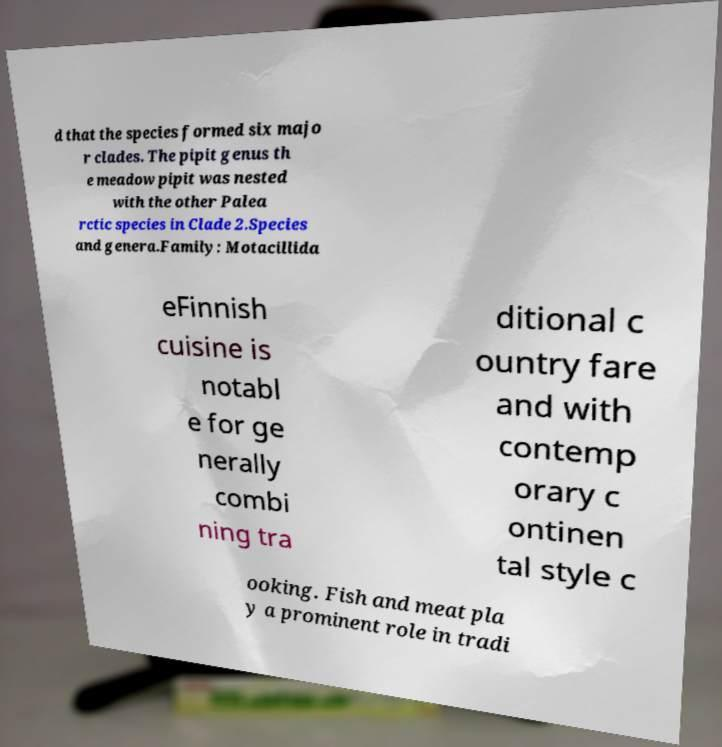For documentation purposes, I need the text within this image transcribed. Could you provide that? d that the species formed six majo r clades. The pipit genus th e meadow pipit was nested with the other Palea rctic species in Clade 2.Species and genera.Family: Motacillida eFinnish cuisine is notabl e for ge nerally combi ning tra ditional c ountry fare and with contemp orary c ontinen tal style c ooking. Fish and meat pla y a prominent role in tradi 